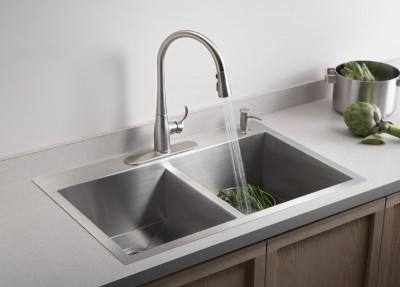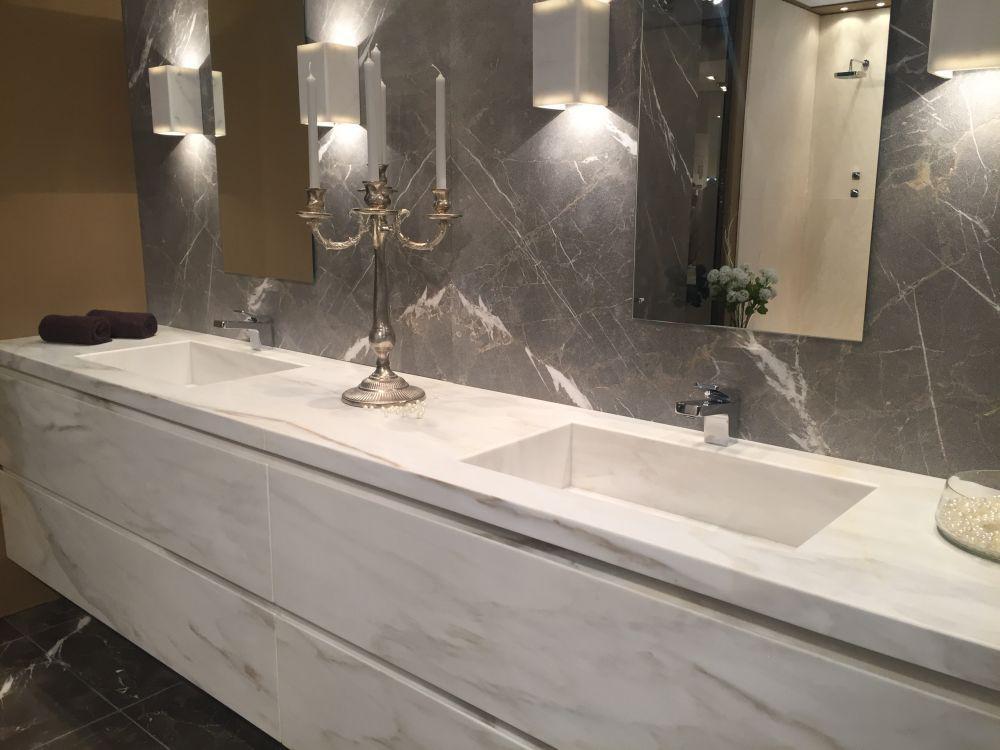The first image is the image on the left, the second image is the image on the right. Evaluate the accuracy of this statement regarding the images: "One image shows a round mirror above a vessel sink on a vanity counter.". Is it true? Answer yes or no. No. The first image is the image on the left, the second image is the image on the right. Analyze the images presented: Is the assertion "There are two sinks in the image on the left." valid? Answer yes or no. Yes. 